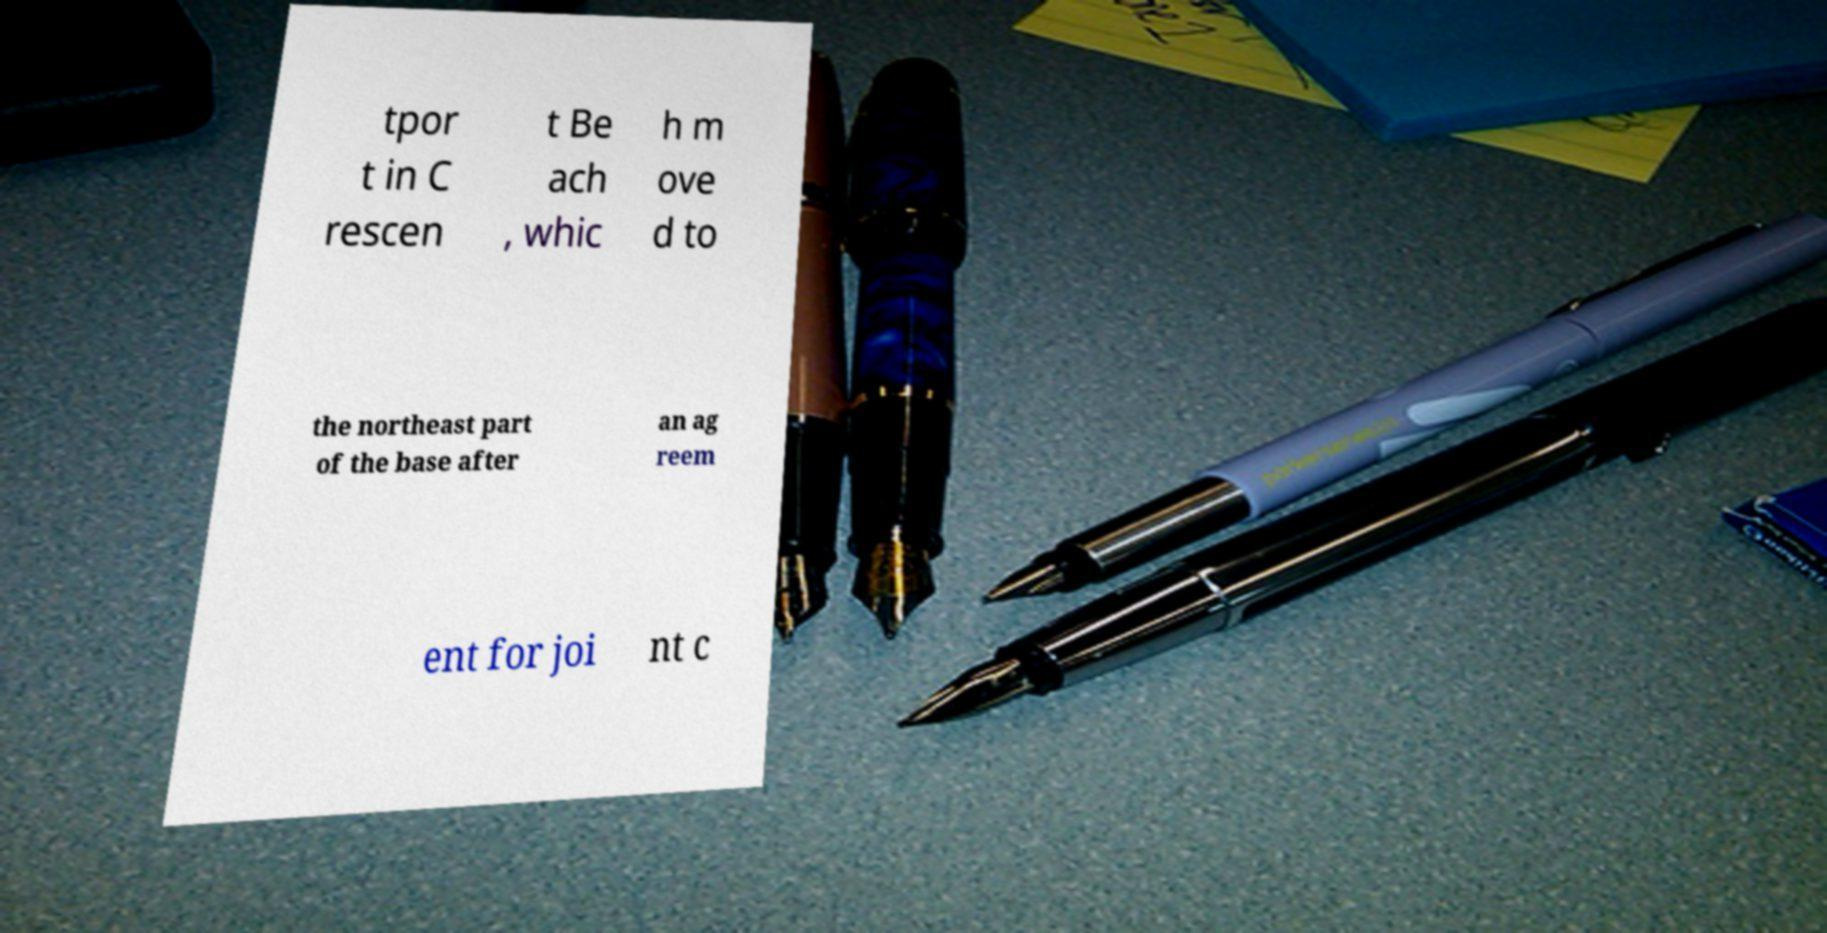Please read and relay the text visible in this image. What does it say? tpor t in C rescen t Be ach , whic h m ove d to the northeast part of the base after an ag reem ent for joi nt c 